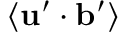<formula> <loc_0><loc_0><loc_500><loc_500>\langle { { u } ^ { \prime } \cdot { b } ^ { \prime } } \rangle</formula> 